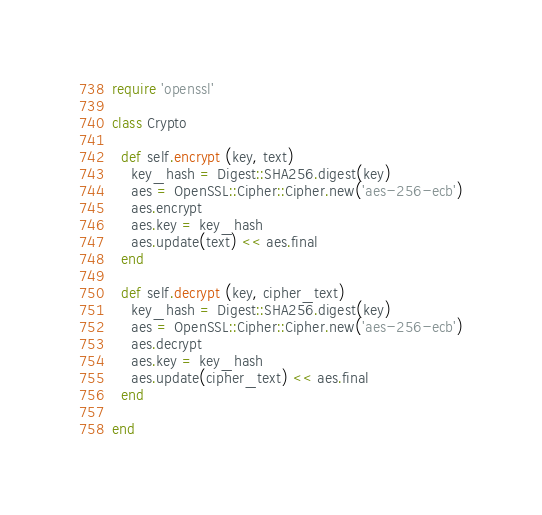<code> <loc_0><loc_0><loc_500><loc_500><_Ruby_>require 'openssl'

class Crypto

  def self.encrypt (key, text)
    key_hash = Digest::SHA256.digest(key)
    aes = OpenSSL::Cipher::Cipher.new('aes-256-ecb')
    aes.encrypt
    aes.key = key_hash
    aes.update(text) << aes.final
  end

  def self.decrypt (key, cipher_text)
    key_hash = Digest::SHA256.digest(key)
    aes = OpenSSL::Cipher::Cipher.new('aes-256-ecb')
    aes.decrypt
    aes.key = key_hash
    aes.update(cipher_text) << aes.final
  end

end
</code> 